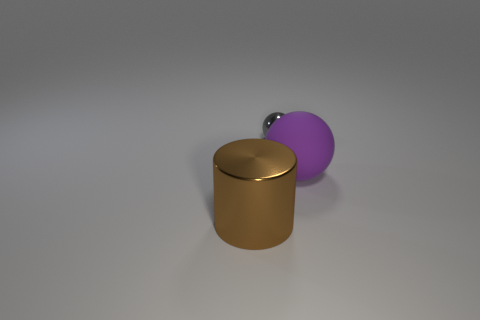Subtract all gray spheres. Subtract all red cubes. How many spheres are left? 1 Add 2 small blue rubber blocks. How many objects exist? 5 Subtract all cylinders. How many objects are left? 2 Subtract all tiny gray spheres. Subtract all big things. How many objects are left? 0 Add 1 big brown metal cylinders. How many big brown metal cylinders are left? 2 Add 1 tiny metallic balls. How many tiny metallic balls exist? 2 Subtract 0 red cubes. How many objects are left? 3 